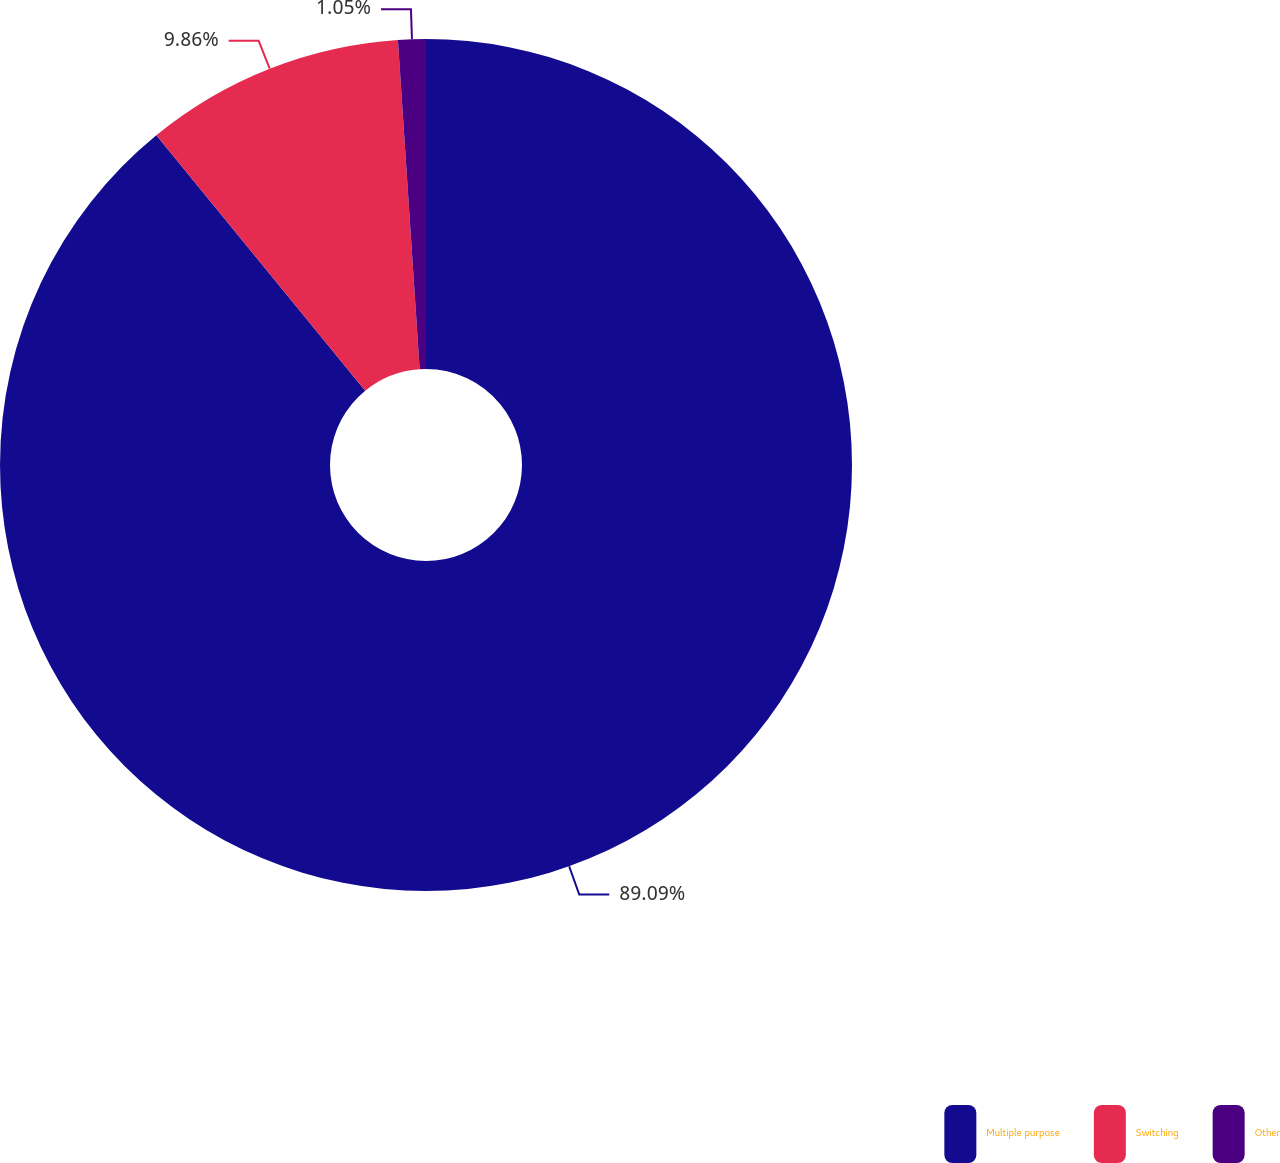<chart> <loc_0><loc_0><loc_500><loc_500><pie_chart><fcel>Multiple purpose<fcel>Switching<fcel>Other<nl><fcel>89.09%<fcel>9.86%<fcel>1.05%<nl></chart> 